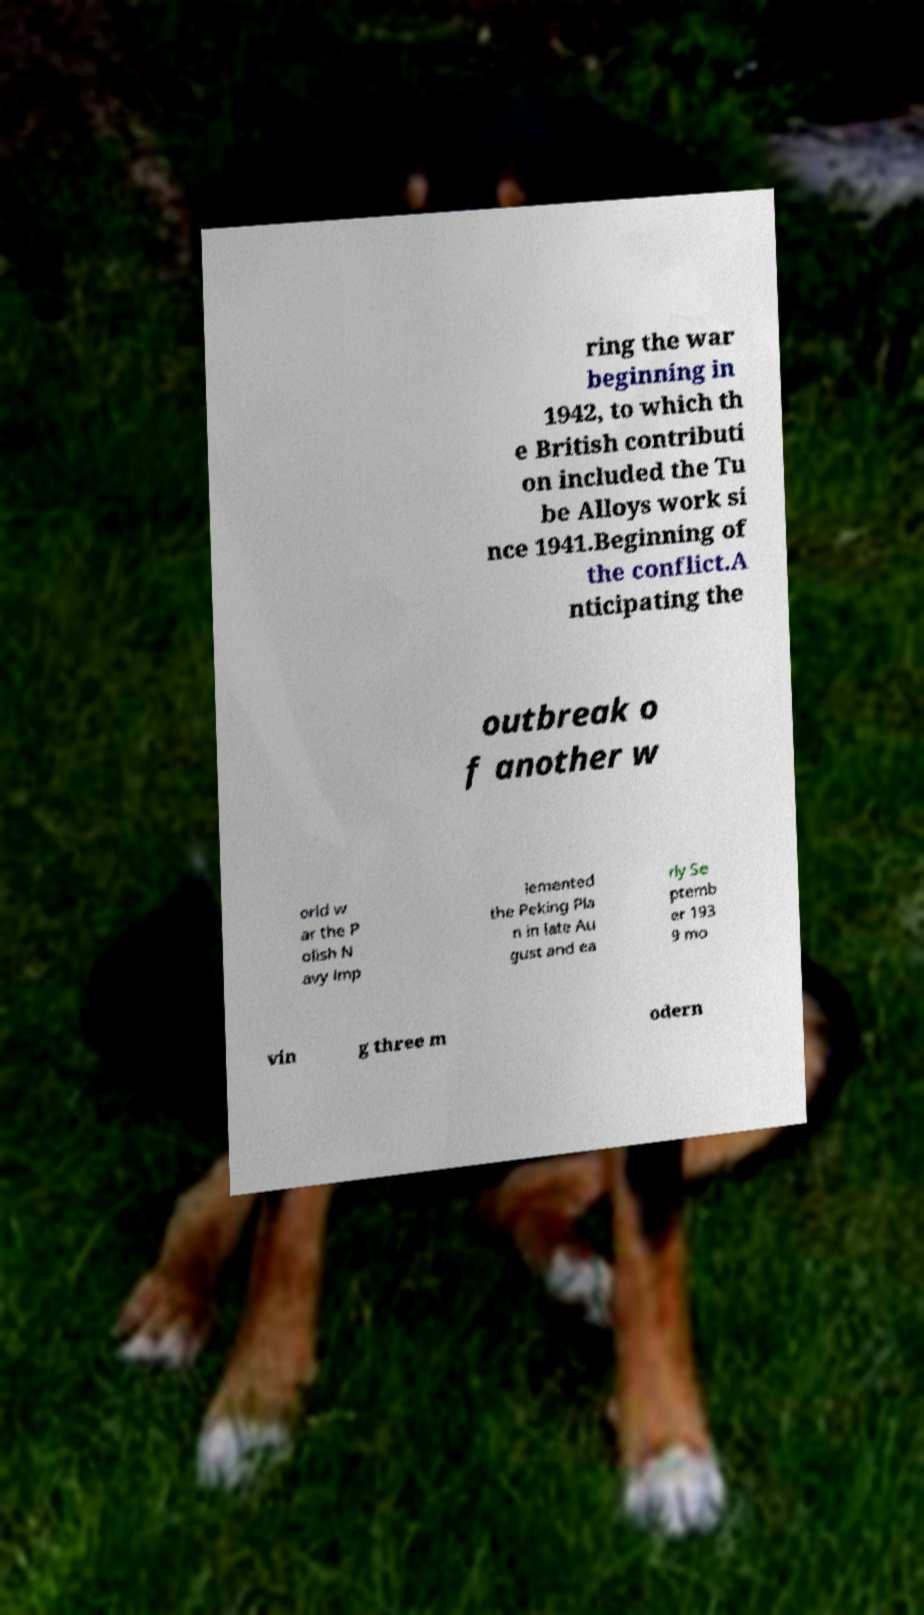I need the written content from this picture converted into text. Can you do that? ring the war beginning in 1942, to which th e British contributi on included the Tu be Alloys work si nce 1941.Beginning of the conflict.A nticipating the outbreak o f another w orld w ar the P olish N avy imp lemented the Peking Pla n in late Au gust and ea rly Se ptemb er 193 9 mo vin g three m odern 